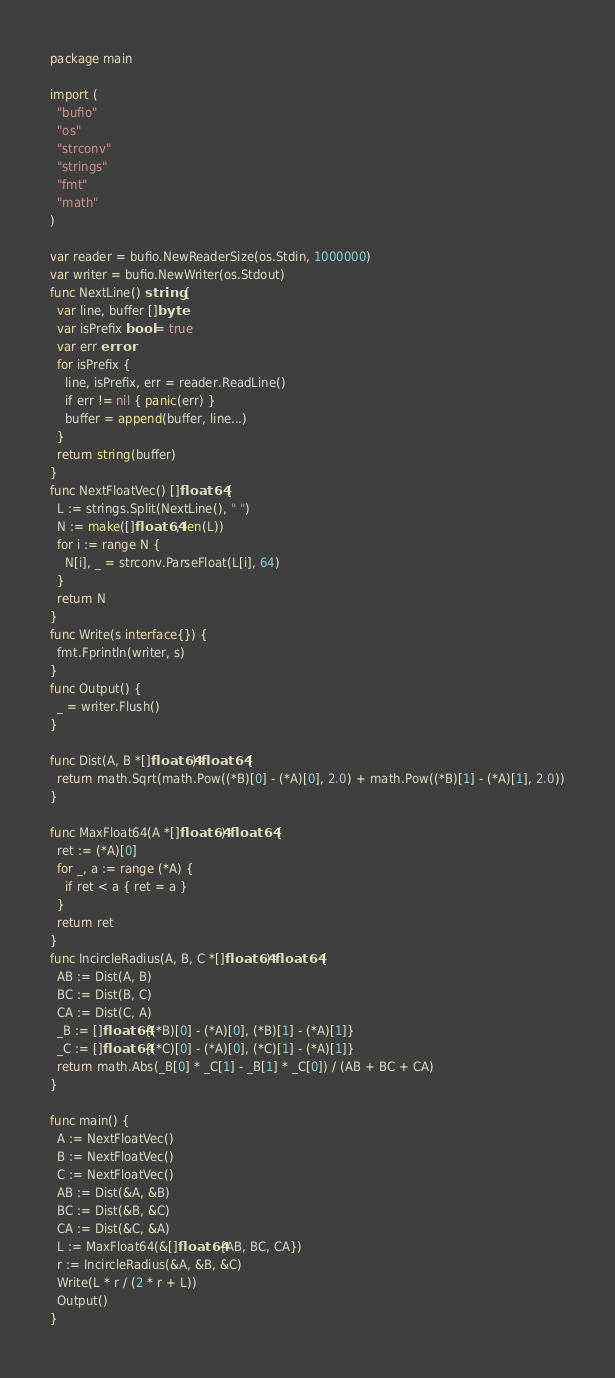<code> <loc_0><loc_0><loc_500><loc_500><_Go_>package main

import (
  "bufio"
  "os"
  "strconv"
  "strings"
  "fmt"
  "math"
)

var reader = bufio.NewReaderSize(os.Stdin, 1000000)
var writer = bufio.NewWriter(os.Stdout)
func NextLine() string {
  var line, buffer []byte
  var isPrefix bool = true
  var err error
  for isPrefix {
    line, isPrefix, err = reader.ReadLine()
    if err != nil { panic(err) }
    buffer = append(buffer, line...)
  }
  return string(buffer)
}
func NextFloatVec() []float64 {
  L := strings.Split(NextLine(), " ")
  N := make([]float64, len(L))
  for i := range N {
    N[i], _ = strconv.ParseFloat(L[i], 64)
  }
  return N
}
func Write(s interface{}) {
  fmt.Fprintln(writer, s)
}
func Output() {
  _ = writer.Flush()
}

func Dist(A, B *[]float64) float64 {
  return math.Sqrt(math.Pow((*B)[0] - (*A)[0], 2.0) + math.Pow((*B)[1] - (*A)[1], 2.0))
}

func MaxFloat64(A *[]float64) float64 {
  ret := (*A)[0]
  for _, a := range (*A) {
    if ret < a { ret = a }
  }
  return ret
}
func IncircleRadius(A, B, C *[]float64) float64 {
  AB := Dist(A, B)
  BC := Dist(B, C)
  CA := Dist(C, A)
  _B := []float64{(*B)[0] - (*A)[0], (*B)[1] - (*A)[1]}
  _C := []float64{(*C)[0] - (*A)[0], (*C)[1] - (*A)[1]}
  return math.Abs(_B[0] * _C[1] - _B[1] * _C[0]) / (AB + BC + CA)
}

func main() {
  A := NextFloatVec()
  B := NextFloatVec()
  C := NextFloatVec()
  AB := Dist(&A, &B)
  BC := Dist(&B, &C)
  CA := Dist(&C, &A)
  L := MaxFloat64(&[]float64{AB, BC, CA})
  r := IncircleRadius(&A, &B, &C)
  Write(L * r / (2 * r + L))
  Output()
}</code> 